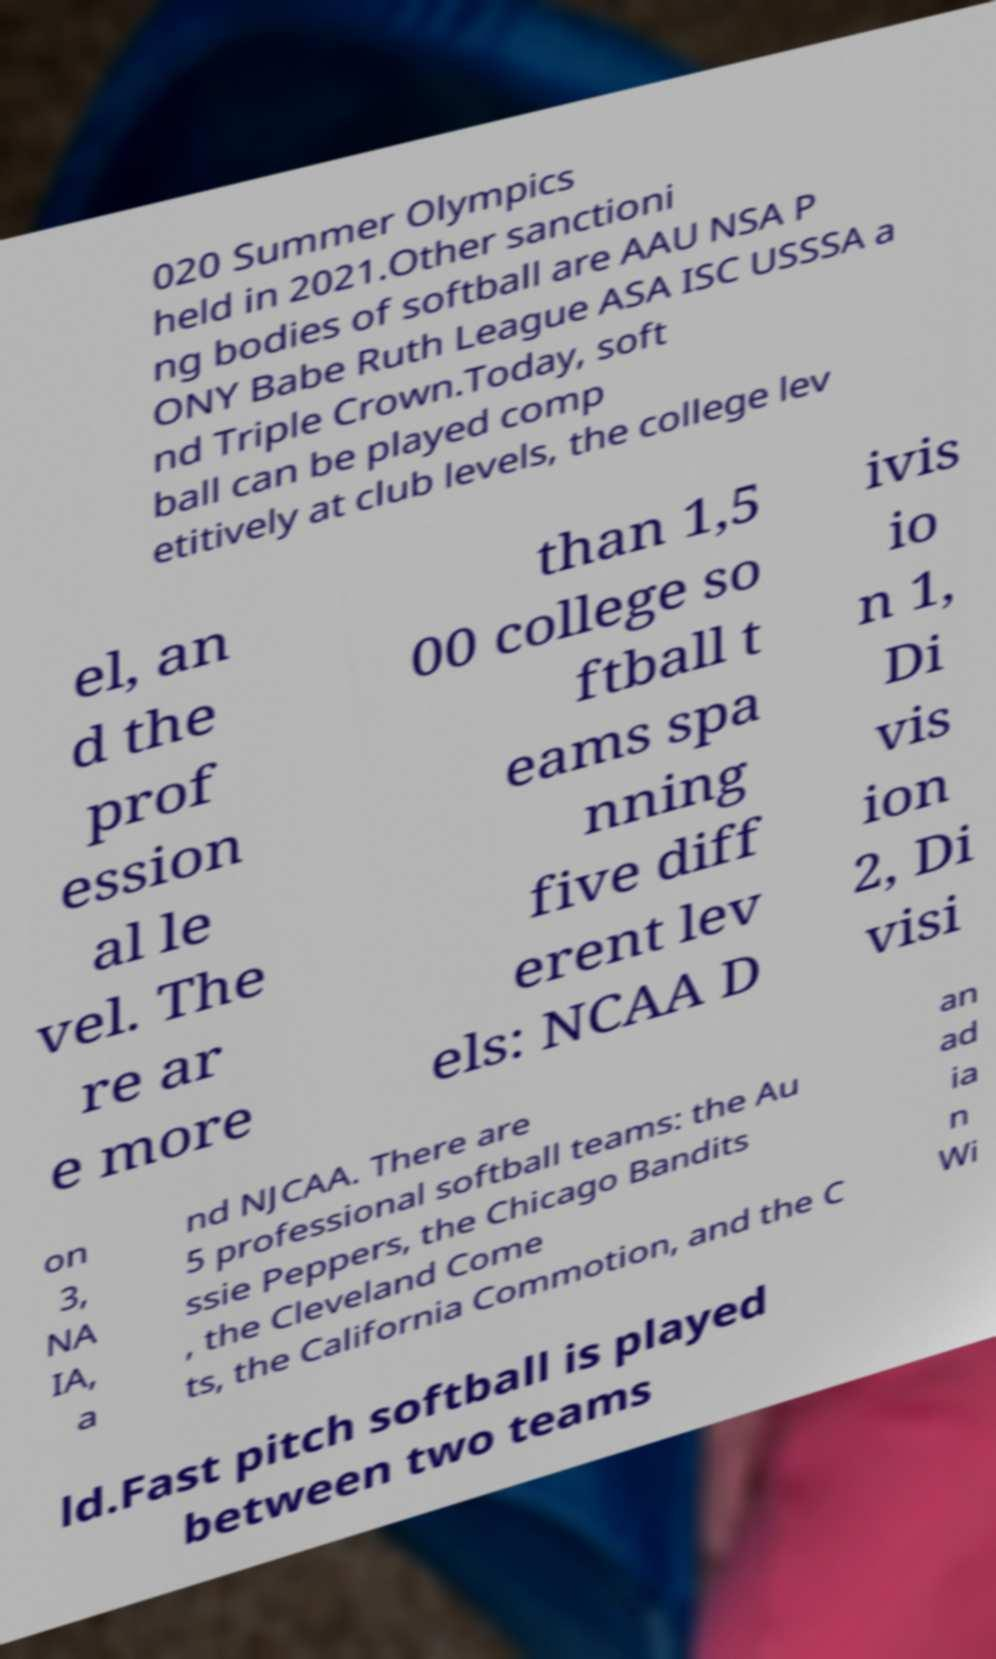There's text embedded in this image that I need extracted. Can you transcribe it verbatim? 020 Summer Olympics held in 2021.Other sanctioni ng bodies of softball are AAU NSA P ONY Babe Ruth League ASA ISC USSSA a nd Triple Crown.Today, soft ball can be played comp etitively at club levels, the college lev el, an d the prof ession al le vel. The re ar e more than 1,5 00 college so ftball t eams spa nning five diff erent lev els: NCAA D ivis io n 1, Di vis ion 2, Di visi on 3, NA IA, a nd NJCAA. There are 5 professional softball teams: the Au ssie Peppers, the Chicago Bandits , the Cleveland Come ts, the California Commotion, and the C an ad ia n Wi ld.Fast pitch softball is played between two teams 